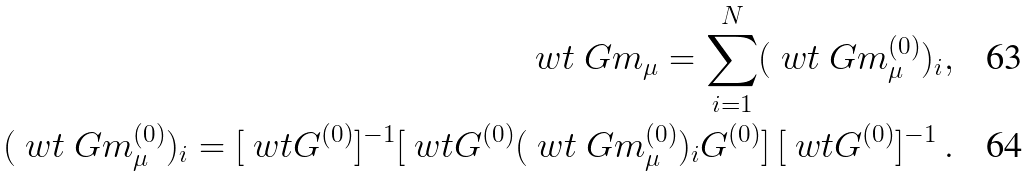<formula> <loc_0><loc_0><loc_500><loc_500>\ w t \ G m _ { \mu } = \sum _ { i = 1 } ^ { N } ( \ w t \ G m _ { \mu } ^ { ( 0 ) } ) _ { i } , \\ ( \ w t \ G m _ { \mu } ^ { ( 0 ) } ) _ { i } = [ \ w t G ^ { ( 0 ) } ] ^ { - 1 } [ \ w t { G ^ { ( 0 ) } ( \ w t \ G m _ { \mu } ^ { ( 0 ) } ) _ { i } G ^ { ( 0 ) } } ] \, [ \ w t G ^ { ( 0 ) } ] ^ { - 1 } \, .</formula> 